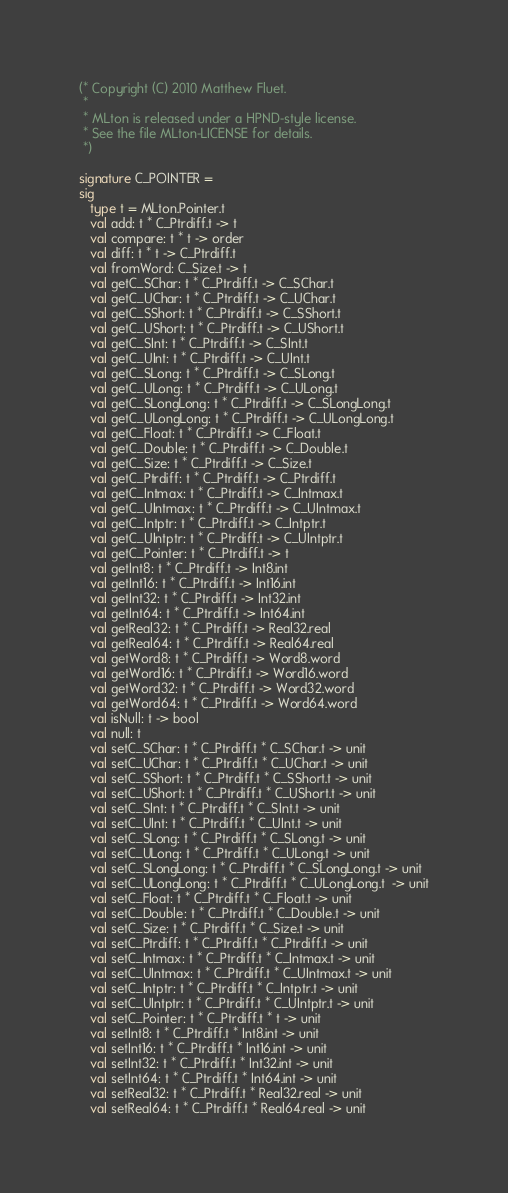Convert code to text. <code><loc_0><loc_0><loc_500><loc_500><_SML_>(* Copyright (C) 2010 Matthew Fluet.
 *
 * MLton is released under a HPND-style license.
 * See the file MLton-LICENSE for details.
 *)

signature C_POINTER =
sig
   type t = MLton.Pointer.t
   val add: t * C_Ptrdiff.t -> t
   val compare: t * t -> order
   val diff: t * t -> C_Ptrdiff.t
   val fromWord: C_Size.t -> t
   val getC_SChar: t * C_Ptrdiff.t -> C_SChar.t
   val getC_UChar: t * C_Ptrdiff.t -> C_UChar.t
   val getC_SShort: t * C_Ptrdiff.t -> C_SShort.t
   val getC_UShort: t * C_Ptrdiff.t -> C_UShort.t
   val getC_SInt: t * C_Ptrdiff.t -> C_SInt.t
   val getC_UInt: t * C_Ptrdiff.t -> C_UInt.t
   val getC_SLong: t * C_Ptrdiff.t -> C_SLong.t
   val getC_ULong: t * C_Ptrdiff.t -> C_ULong.t
   val getC_SLongLong: t * C_Ptrdiff.t -> C_SLongLong.t
   val getC_ULongLong: t * C_Ptrdiff.t -> C_ULongLong.t
   val getC_Float: t * C_Ptrdiff.t -> C_Float.t
   val getC_Double: t * C_Ptrdiff.t -> C_Double.t
   val getC_Size: t * C_Ptrdiff.t -> C_Size.t
   val getC_Ptrdiff: t * C_Ptrdiff.t -> C_Ptrdiff.t
   val getC_Intmax: t * C_Ptrdiff.t -> C_Intmax.t
   val getC_UIntmax: t * C_Ptrdiff.t -> C_UIntmax.t
   val getC_Intptr: t * C_Ptrdiff.t -> C_Intptr.t
   val getC_UIntptr: t * C_Ptrdiff.t -> C_UIntptr.t
   val getC_Pointer: t * C_Ptrdiff.t -> t
   val getInt8: t * C_Ptrdiff.t -> Int8.int
   val getInt16: t * C_Ptrdiff.t -> Int16.int
   val getInt32: t * C_Ptrdiff.t -> Int32.int
   val getInt64: t * C_Ptrdiff.t -> Int64.int
   val getReal32: t * C_Ptrdiff.t -> Real32.real
   val getReal64: t * C_Ptrdiff.t -> Real64.real
   val getWord8: t * C_Ptrdiff.t -> Word8.word
   val getWord16: t * C_Ptrdiff.t -> Word16.word
   val getWord32: t * C_Ptrdiff.t -> Word32.word
   val getWord64: t * C_Ptrdiff.t -> Word64.word
   val isNull: t -> bool
   val null: t
   val setC_SChar: t * C_Ptrdiff.t * C_SChar.t -> unit
   val setC_UChar: t * C_Ptrdiff.t * C_UChar.t -> unit
   val setC_SShort: t * C_Ptrdiff.t * C_SShort.t -> unit
   val setC_UShort: t * C_Ptrdiff.t * C_UShort.t -> unit
   val setC_SInt: t * C_Ptrdiff.t * C_SInt.t -> unit
   val setC_UInt: t * C_Ptrdiff.t * C_UInt.t -> unit
   val setC_SLong: t * C_Ptrdiff.t * C_SLong.t -> unit
   val setC_ULong: t * C_Ptrdiff.t * C_ULong.t -> unit
   val setC_SLongLong: t * C_Ptrdiff.t * C_SLongLong.t -> unit
   val setC_ULongLong: t * C_Ptrdiff.t * C_ULongLong.t  -> unit
   val setC_Float: t * C_Ptrdiff.t * C_Float.t -> unit
   val setC_Double: t * C_Ptrdiff.t * C_Double.t -> unit
   val setC_Size: t * C_Ptrdiff.t * C_Size.t -> unit
   val setC_Ptrdiff: t * C_Ptrdiff.t * C_Ptrdiff.t -> unit
   val setC_Intmax: t * C_Ptrdiff.t * C_Intmax.t -> unit
   val setC_UIntmax: t * C_Ptrdiff.t * C_UIntmax.t -> unit
   val setC_Intptr: t * C_Ptrdiff.t * C_Intptr.t -> unit
   val setC_UIntptr: t * C_Ptrdiff.t * C_UIntptr.t -> unit
   val setC_Pointer: t * C_Ptrdiff.t * t -> unit
   val setInt8: t * C_Ptrdiff.t * Int8.int -> unit
   val setInt16: t * C_Ptrdiff.t * Int16.int -> unit
   val setInt32: t * C_Ptrdiff.t * Int32.int -> unit
   val setInt64: t * C_Ptrdiff.t * Int64.int -> unit
   val setReal32: t * C_Ptrdiff.t * Real32.real -> unit
   val setReal64: t * C_Ptrdiff.t * Real64.real -> unit</code> 